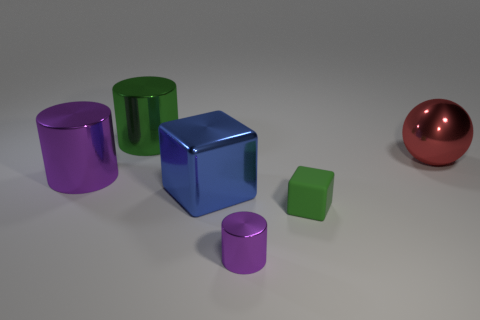Add 3 green metal things. How many objects exist? 9 Subtract all spheres. How many objects are left? 5 Add 4 small green matte objects. How many small green matte objects are left? 5 Add 5 large things. How many large things exist? 9 Subtract 0 brown cylinders. How many objects are left? 6 Subtract all blue cylinders. Subtract all big metallic things. How many objects are left? 2 